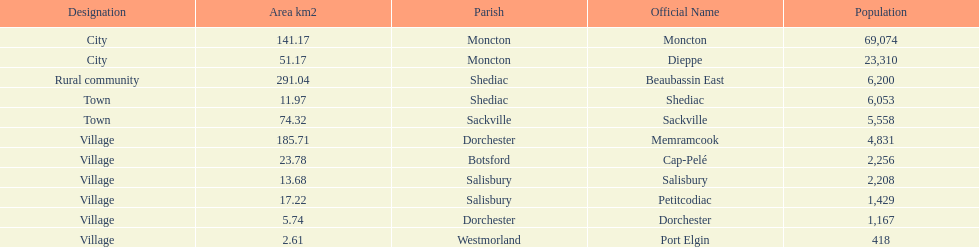City in the same parish of moncton Dieppe. 